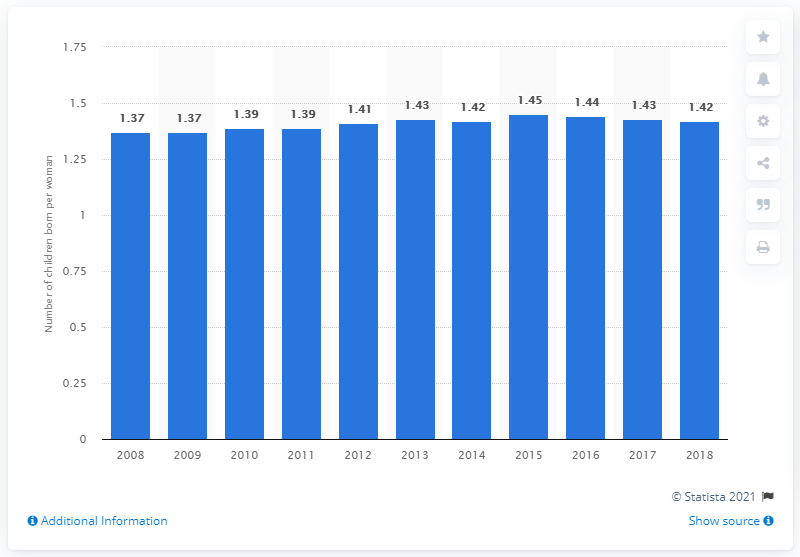List a handful of essential elements in this visual. In 2018, Japan's total fertility rate was 1.42, representing a decline from the previous year and a continuation of a long-term trend of low fertility rates. 